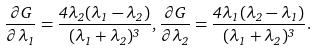<formula> <loc_0><loc_0><loc_500><loc_500>\frac { \partial G } { \partial \lambda _ { 1 } } = \frac { 4 \lambda _ { 2 } ( \lambda _ { 1 } - \lambda _ { 2 } ) } { ( \lambda _ { 1 } + \lambda _ { 2 } ) ^ { 3 } } , \frac { \partial G } { \partial \lambda _ { 2 } } = \frac { 4 \lambda _ { 1 } ( \lambda _ { 2 } - \lambda _ { 1 } ) } { ( \lambda _ { 1 } + \lambda _ { 2 } ) ^ { 3 } } .</formula> 